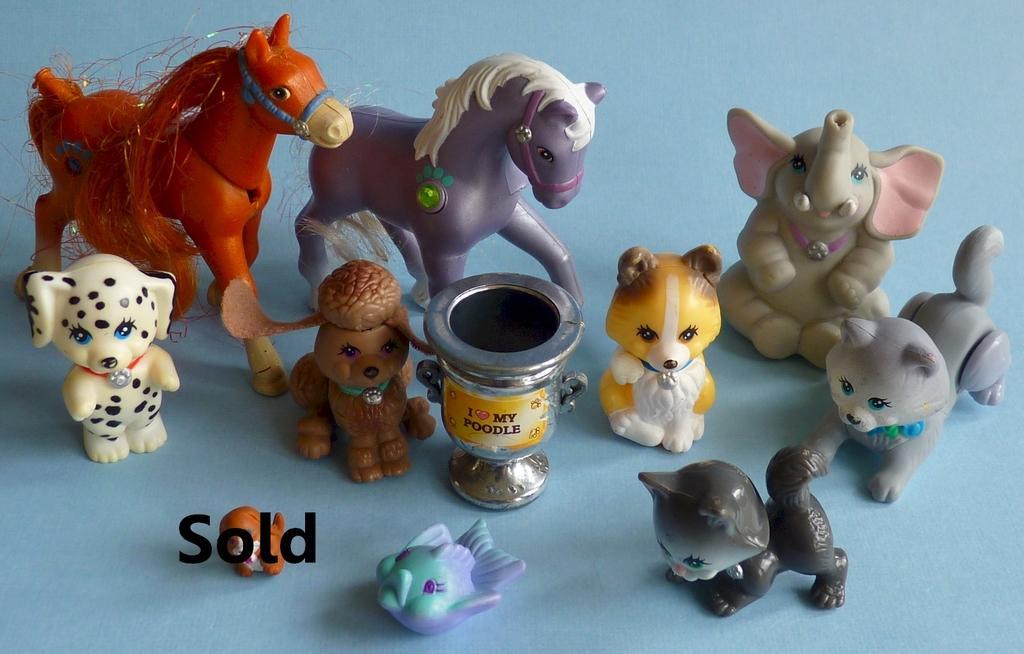How would you summarize this image in a sentence or two? In this image there are toys, there is text, the background of the image is blue in color. 